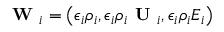Convert formula to latex. <formula><loc_0><loc_0><loc_500><loc_500>W _ { i } = \left ( \epsilon _ { i } \rho _ { i } , \epsilon _ { i } \rho _ { i } U _ { i } , \epsilon _ { i } \rho _ { i } E _ { i } \right )</formula> 